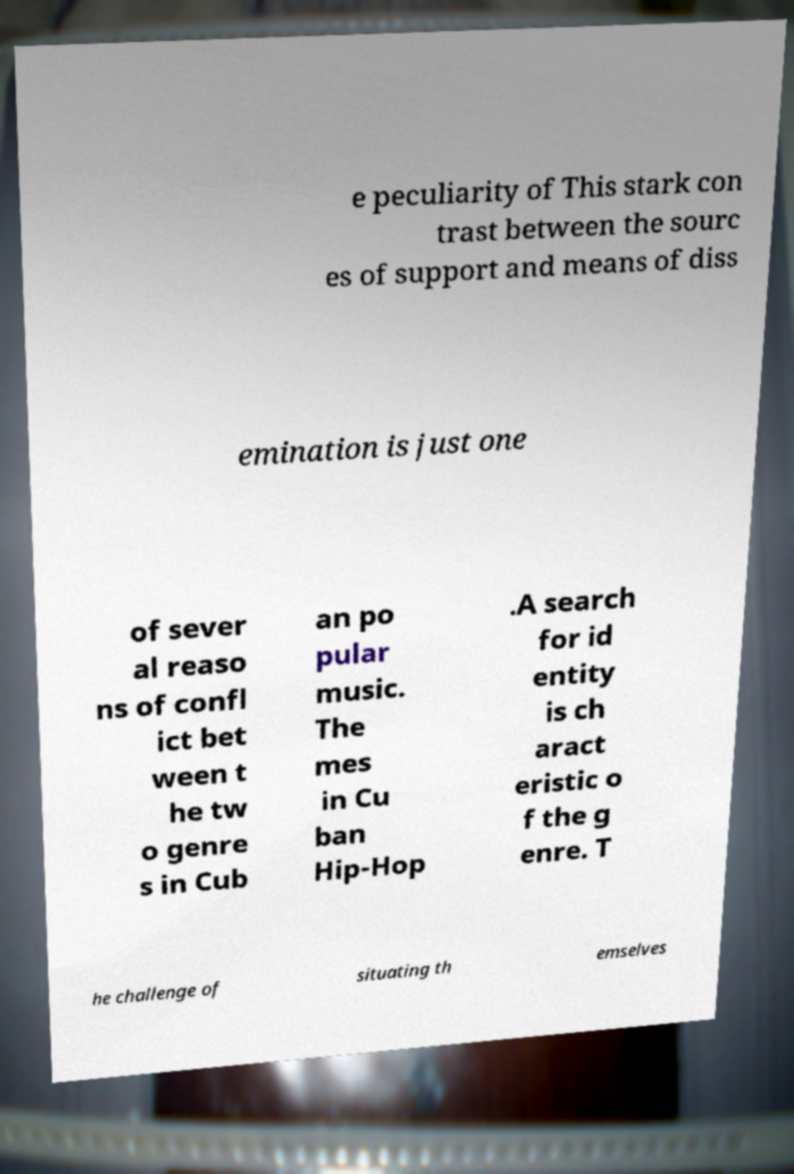Please read and relay the text visible in this image. What does it say? e peculiarity of This stark con trast between the sourc es of support and means of diss emination is just one of sever al reaso ns of confl ict bet ween t he tw o genre s in Cub an po pular music. The mes in Cu ban Hip-Hop .A search for id entity is ch aract eristic o f the g enre. T he challenge of situating th emselves 